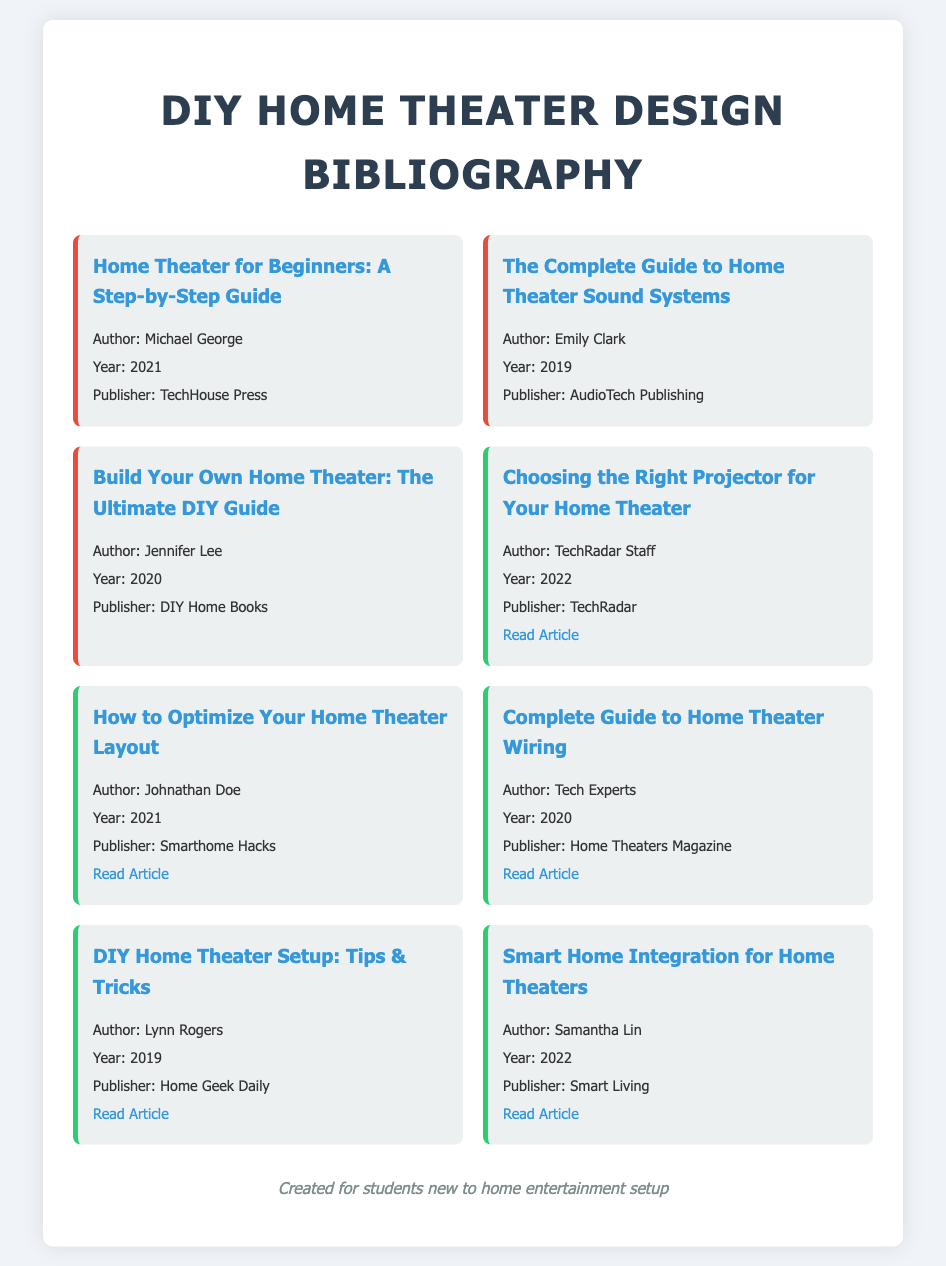what is the title of the first book? The title of the first book is provided in the document under the book entries.
Answer: Home Theater for Beginners: A Step-by-Step Guide who is the author of "The Complete Guide to Home Theater Sound Systems"? The author is listed in the document beneath the title of the book.
Answer: Emily Clark what year was "Build Your Own Home Theater: The Ultimate DIY Guide" published? The publication year is stated in the book entry for this title.
Answer: 2020 how many articles are listed in the bibliography? The total number of articles can be counted from the entries in the document.
Answer: 6 which publisher released "DIY Home Theater Setup: Tips & Tricks"? The publisher is mentioned within the article entry for this title.
Answer: Home Geek Daily what is the main focus of the article written by TechRadar Staff? The article title provides an indication of its focus area related to home theaters.
Answer: Choosing the Right Projector for Your Home Theater what is the publication year of the article "How to Optimize Your Home Theater Layout"? The publication year is indicated in the article entry for this title.
Answer: 2021 which entry type has a border color of red? The entry type can be determined by looking at the styling mentioned in the document.
Answer: book who is the author of the article related to smart home integration? The author's name is specified in the article entry associated with this topic.
Answer: Samantha Lin 